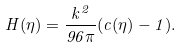Convert formula to latex. <formula><loc_0><loc_0><loc_500><loc_500>H ( \eta ) = \frac { k ^ { 2 } } { 9 6 \pi } ( c ( \eta ) - 1 ) .</formula> 